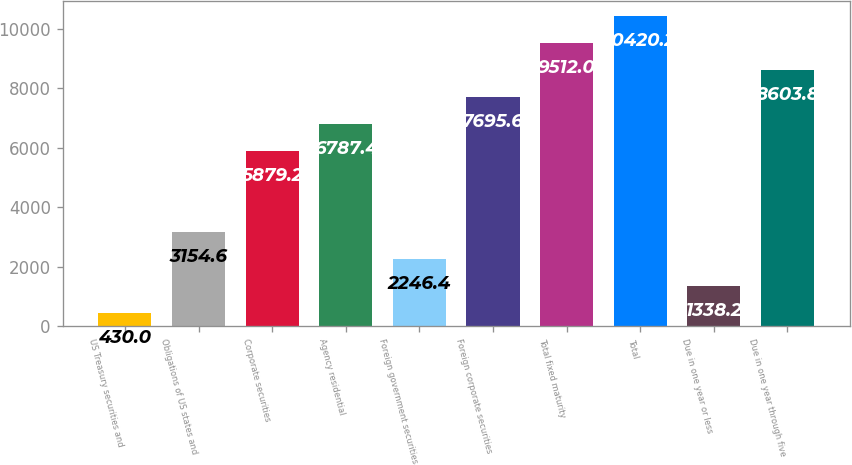Convert chart to OTSL. <chart><loc_0><loc_0><loc_500><loc_500><bar_chart><fcel>US Treasury securities and<fcel>Obligations of US states and<fcel>Corporate securities<fcel>Agency residential<fcel>Foreign government securities<fcel>Foreign corporate securities<fcel>Total fixed maturity<fcel>Total<fcel>Due in one year or less<fcel>Due in one year through five<nl><fcel>430<fcel>3154.6<fcel>5879.2<fcel>6787.4<fcel>2246.4<fcel>7695.6<fcel>9512<fcel>10420.2<fcel>1338.2<fcel>8603.8<nl></chart> 